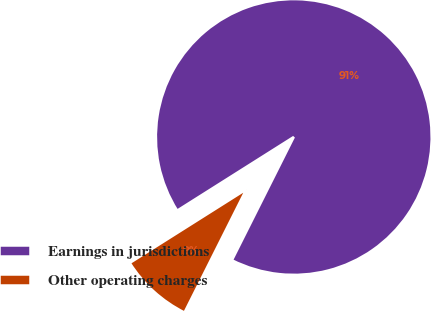Convert chart. <chart><loc_0><loc_0><loc_500><loc_500><pie_chart><fcel>Earnings in jurisdictions<fcel>Other operating charges<nl><fcel>91.37%<fcel>8.63%<nl></chart> 